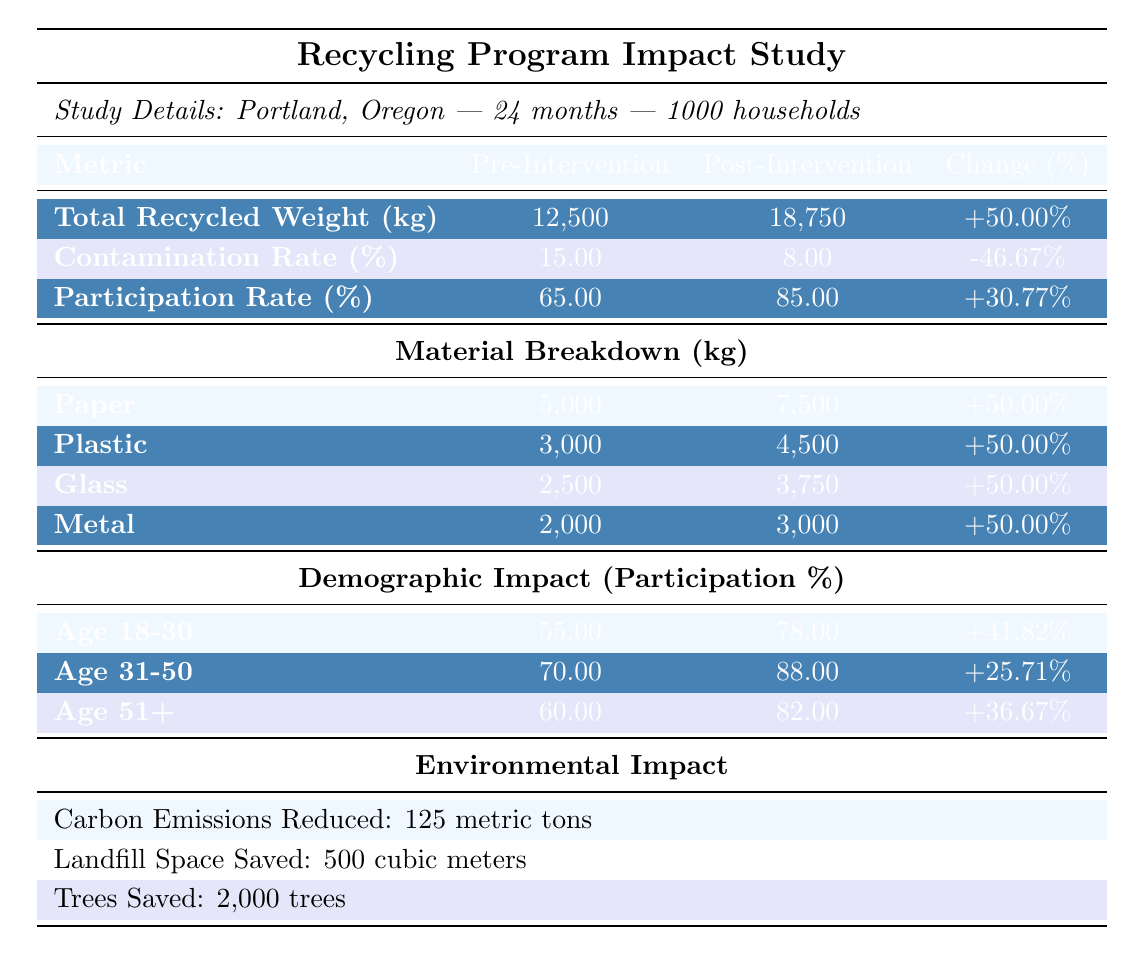What was the total recycled weight before the educational interventions? The table states that the total recycled weight before the educational interventions was 12,500 kg.
Answer: 12,500 kg What is the contamination rate after the educational interventions? According to the table, the contamination rate after the educational interventions is 8%.
Answer: 8% Which material had the highest increase in recycled weight? The table shows that Paper, Plastic, Glass, and Metal all had a 50% increase, but since we are looking at the specific weight, Paper had the highest recycled weight post-intervention at 7,500 kg, which is the highest compared to the others.
Answer: Paper What is the total increase in participation rate from before to after the interventions? The pre-intervention participation rate was 65% and post-intervention was 85%. To find the total increase, subtract the pre-intervention value from the post-intervention value: 85% - 65% = 20%.
Answer: 20% Which age group showed the highest percentage increase in participation? By comparing the percentage increases, Age 18-30 increased from 55% to 78%, Age 31-50 from 70% to 88%, and Age 51+ from 60% to 82%. Age 18-30 shows the largest increase of 41.82%.
Answer: Age 18-30 Was there a decrease in contamination rate after the interventions? The pre-intervention contamination rate was 15% and post-intervention was 8%. Since 8% is less than 15%, this indicates a decrease.
Answer: Yes What is the average percentage change across all recycling metrics presented in the table? To find the average percentage change, sum all the percentage changes: +50% (Total Recycled Weight) + -46.67% (Contamination Rate) + +30.77% (Participation Rate) = 34.10%, then divide by the number of metrics (3): 34.10% / 3 = 11.37%.
Answer: 11.37% How many trees were saved as a result of the interventions? The table indicates that 2,000 trees were saved as a result of the interventions.
Answer: 2,000 trees What is the total reduction in carbon emissions from the recycling program? The table shows a reduction of 125 metric tons in carbon emissions as a result of the recycling program.
Answer: 125 metric tons Which material had a pre-intervention weight of 3,000 kg? The table indicates that Plastic had a pre-intervention weight of 3,000 kg, as listed in the material breakdown section.
Answer: Plastic If we combine the post-intervention weights of all materials, what is the total recycled weight? The post-intervention weights are: Paper (7,500 kg) + Plastic (4,500 kg) + Glass (3,750 kg) + Metal (3,000 kg). Summing these gives: 7,500 + 4,500 + 3,750 + 3,000 = 18,750 kg.
Answer: 18,750 kg 